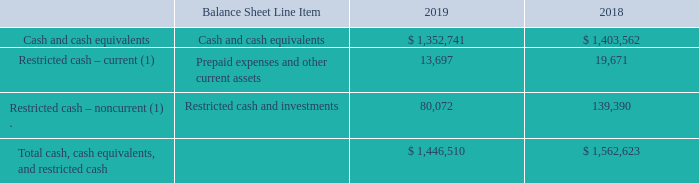The following table provides a reconciliation of cash, cash equivalents, and restricted cash reported within our consolidated balance sheets as of December 31, 2019 and 2018 to the total of such amounts as presented in the consolidated statements of cash flows (in thousands):
(1) See Note 7. “Restricted Cash and Investments” to our consolidated financial statements for discussion of our “Restricted cash” arrangements.
During the year ended December 31, 2019, we sold marketable securities for proceeds of $52.0 million and realized no gain or loss on such sales. During the years ended December 31, 2018 and 2017, we sold marketable securities for proceeds of $10.8 million and $118.3 million, respectively, and realized gains of less than $0.1 million on such sales in each respective period. See Note 11. “Fair Value Measurements” to our consolidated financial statements for information about the fair value of our marketable securities.
What amount of marketable securities were sold in 2019? During the year ended december 31, 2019, we sold marketable securities for proceeds of $52.0 million and realized no gain or loss on such sales. What amount of marketable securities were sold in 2017? $118.3 million. What is the proceed recognized for the sale of marketable securities in 2018? Realized gains of less than $0.1 million on such sales in each respective period. What percentage of the total cash, cash equivalents, and restricted cash is made up of restricted cash and investments?
Answer scale should be: percent. 80,072 / 1,446,510 
Answer: 5.54. What percentage of the total cash, cash equivalents, and restricted cash is made up of prepaid expenses and other current assets in 2019?
Answer scale should be: percent. 13,697 / 1,446,510 
Answer: 0.95. What is the percentage decrease in cash and cash equivalents from 2018 to 2019?
Answer scale should be: percent. (1,403,562 - 1,352,741) / 1,403,562 
Answer: 3.62. 